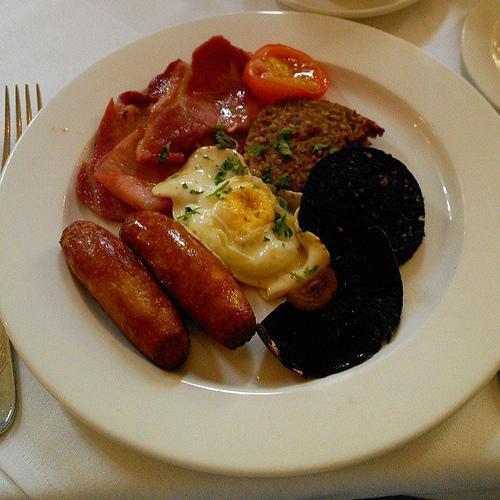How many eggs are in the dish?
Give a very brief answer. 1. 